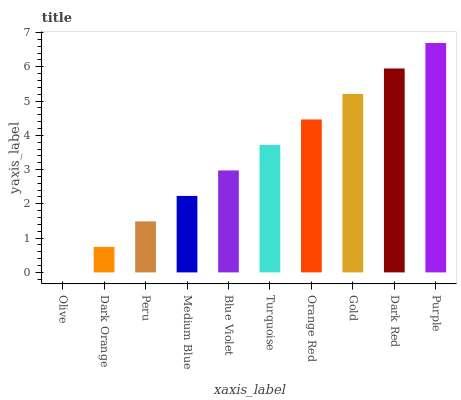Is Olive the minimum?
Answer yes or no. Yes. Is Purple the maximum?
Answer yes or no. Yes. Is Dark Orange the minimum?
Answer yes or no. No. Is Dark Orange the maximum?
Answer yes or no. No. Is Dark Orange greater than Olive?
Answer yes or no. Yes. Is Olive less than Dark Orange?
Answer yes or no. Yes. Is Olive greater than Dark Orange?
Answer yes or no. No. Is Dark Orange less than Olive?
Answer yes or no. No. Is Turquoise the high median?
Answer yes or no. Yes. Is Blue Violet the low median?
Answer yes or no. Yes. Is Orange Red the high median?
Answer yes or no. No. Is Turquoise the low median?
Answer yes or no. No. 